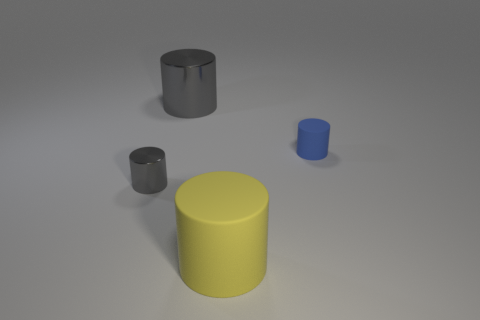Add 3 tiny red things. How many objects exist? 7 Subtract 2 cylinders. How many cylinders are left? 2 Subtract all red cylinders. Subtract all gray balls. How many cylinders are left? 4 Subtract 0 yellow cubes. How many objects are left? 4 Subtract all metallic cylinders. Subtract all yellow matte objects. How many objects are left? 1 Add 1 large cylinders. How many large cylinders are left? 3 Add 3 large rubber cylinders. How many large rubber cylinders exist? 4 